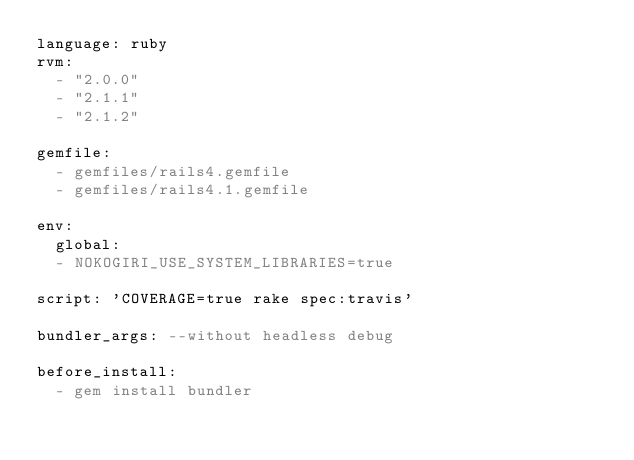Convert code to text. <code><loc_0><loc_0><loc_500><loc_500><_YAML_>language: ruby
rvm:
  - "2.0.0"
  - "2.1.1"
  - "2.1.2"

gemfile:
  - gemfiles/rails4.gemfile
  - gemfiles/rails4.1.gemfile

env:
  global:
  - NOKOGIRI_USE_SYSTEM_LIBRARIES=true

script: 'COVERAGE=true rake spec:travis'

bundler_args: --without headless debug

before_install:
  - gem install bundler
</code> 